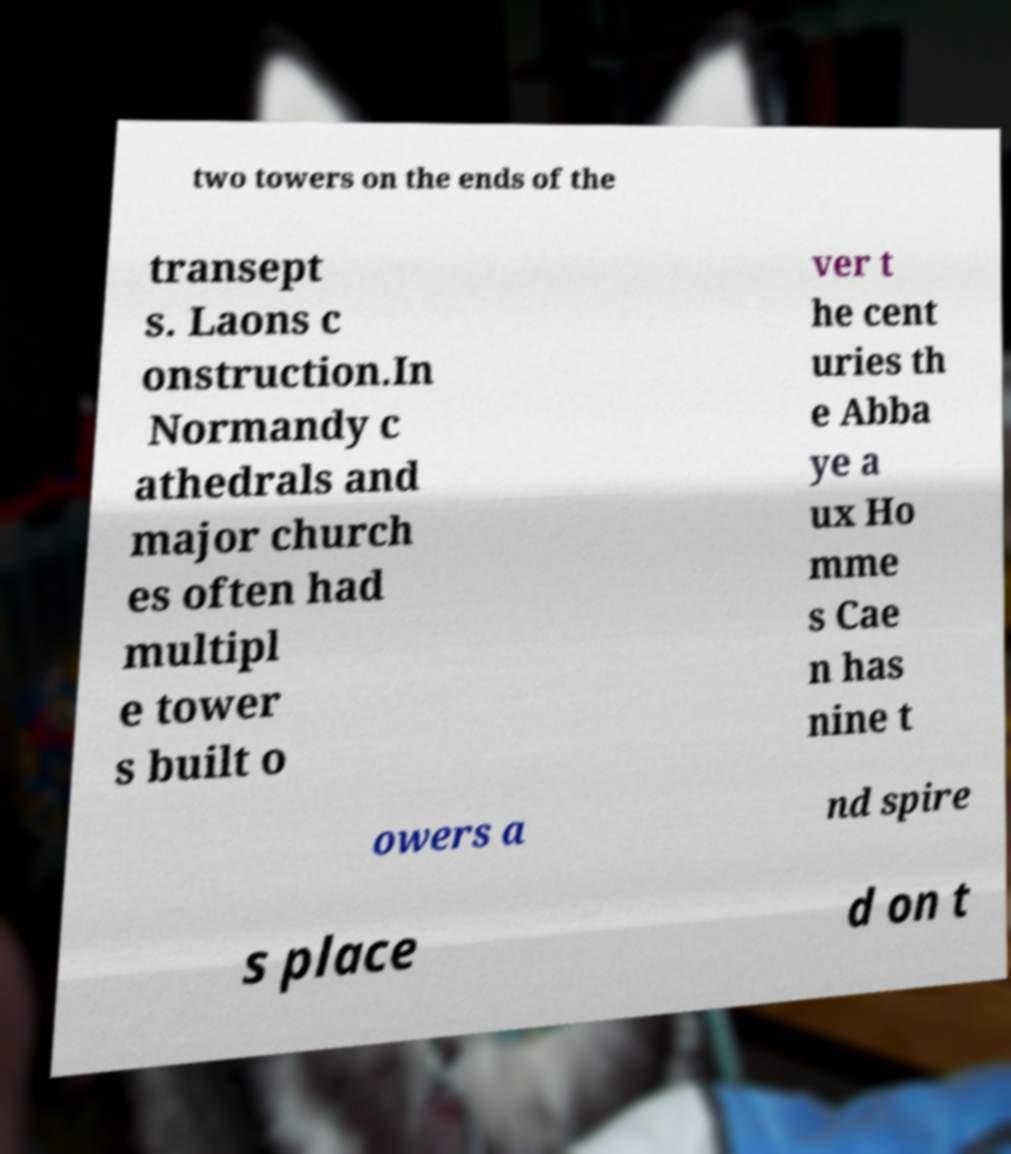Could you assist in decoding the text presented in this image and type it out clearly? two towers on the ends of the transept s. Laons c onstruction.In Normandy c athedrals and major church es often had multipl e tower s built o ver t he cent uries th e Abba ye a ux Ho mme s Cae n has nine t owers a nd spire s place d on t 